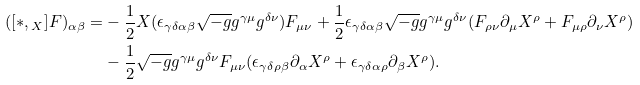<formula> <loc_0><loc_0><loc_500><loc_500>( [ * , \L _ { X } ] F ) _ { \alpha \beta } = & - \frac { 1 } { 2 } X ( \epsilon _ { \gamma \delta \alpha \beta } \sqrt { - g } g ^ { \gamma \mu } g ^ { \delta \nu } ) F _ { \mu \nu } + \frac { 1 } { 2 } \epsilon _ { \gamma \delta \alpha \beta } \sqrt { - g } g ^ { \gamma \mu } g ^ { \delta \nu } ( F _ { \rho \nu } \partial _ { \mu } X ^ { \rho } + F _ { \mu \rho } \partial _ { \nu } X ^ { \rho } ) \\ & - \frac { 1 } { 2 } \sqrt { - g } g ^ { \gamma \mu } g ^ { \delta \nu } F _ { \mu \nu } ( \epsilon _ { \gamma \delta \rho \beta } \partial _ { \alpha } X ^ { \rho } + \epsilon _ { \gamma \delta \alpha \rho } \partial _ { \beta } X ^ { \rho } ) .</formula> 